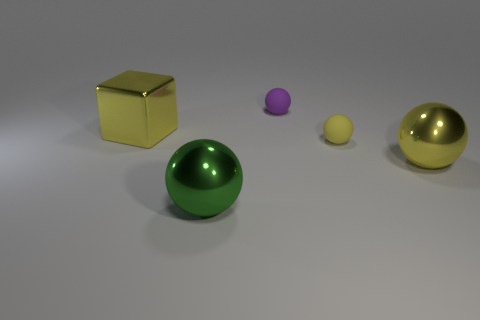What number of yellow things are in front of the yellow matte ball?
Offer a very short reply. 1. Is the material of the purple object the same as the big yellow sphere?
Provide a succinct answer. No. How many objects are in front of the tiny purple rubber ball and right of the big green shiny object?
Provide a short and direct response. 2. What number of other things are the same color as the block?
Give a very brief answer. 2. What number of green things are cubes or big metallic objects?
Offer a very short reply. 1. How big is the yellow rubber sphere?
Provide a succinct answer. Small. What number of matte objects are balls or blocks?
Provide a short and direct response. 2. Is the number of green objects less than the number of large metal spheres?
Offer a terse response. Yes. What number of other things are there of the same material as the green thing
Your answer should be compact. 2. What size is the other metal object that is the same shape as the green thing?
Keep it short and to the point. Large. 